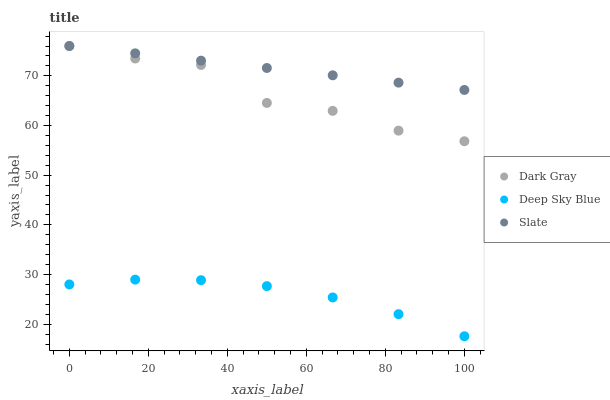Does Deep Sky Blue have the minimum area under the curve?
Answer yes or no. Yes. Does Slate have the maximum area under the curve?
Answer yes or no. Yes. Does Slate have the minimum area under the curve?
Answer yes or no. No. Does Deep Sky Blue have the maximum area under the curve?
Answer yes or no. No. Is Slate the smoothest?
Answer yes or no. Yes. Is Dark Gray the roughest?
Answer yes or no. Yes. Is Deep Sky Blue the smoothest?
Answer yes or no. No. Is Deep Sky Blue the roughest?
Answer yes or no. No. Does Deep Sky Blue have the lowest value?
Answer yes or no. Yes. Does Slate have the lowest value?
Answer yes or no. No. Does Slate have the highest value?
Answer yes or no. Yes. Does Deep Sky Blue have the highest value?
Answer yes or no. No. Is Deep Sky Blue less than Slate?
Answer yes or no. Yes. Is Dark Gray greater than Deep Sky Blue?
Answer yes or no. Yes. Does Dark Gray intersect Slate?
Answer yes or no. Yes. Is Dark Gray less than Slate?
Answer yes or no. No. Is Dark Gray greater than Slate?
Answer yes or no. No. Does Deep Sky Blue intersect Slate?
Answer yes or no. No. 